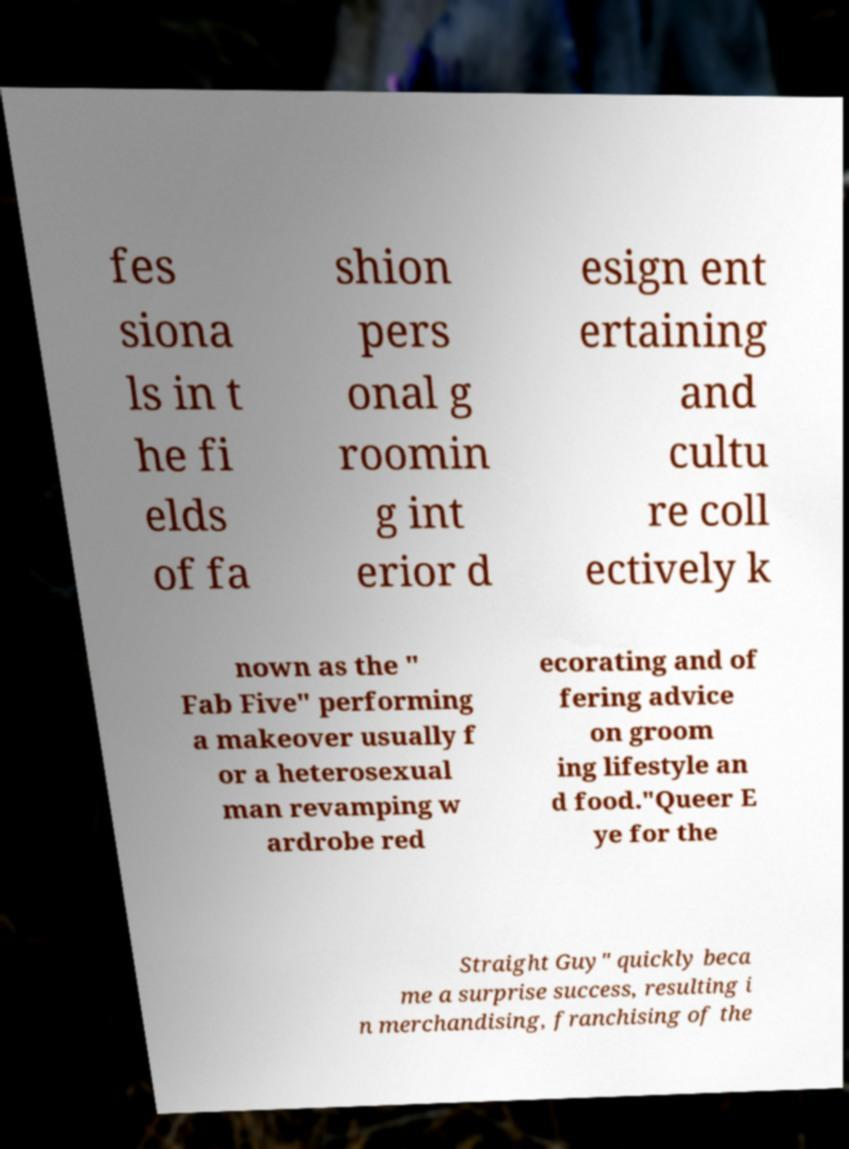There's text embedded in this image that I need extracted. Can you transcribe it verbatim? fes siona ls in t he fi elds of fa shion pers onal g roomin g int erior d esign ent ertaining and cultu re coll ectively k nown as the " Fab Five" performing a makeover usually f or a heterosexual man revamping w ardrobe red ecorating and of fering advice on groom ing lifestyle an d food."Queer E ye for the Straight Guy" quickly beca me a surprise success, resulting i n merchandising, franchising of the 